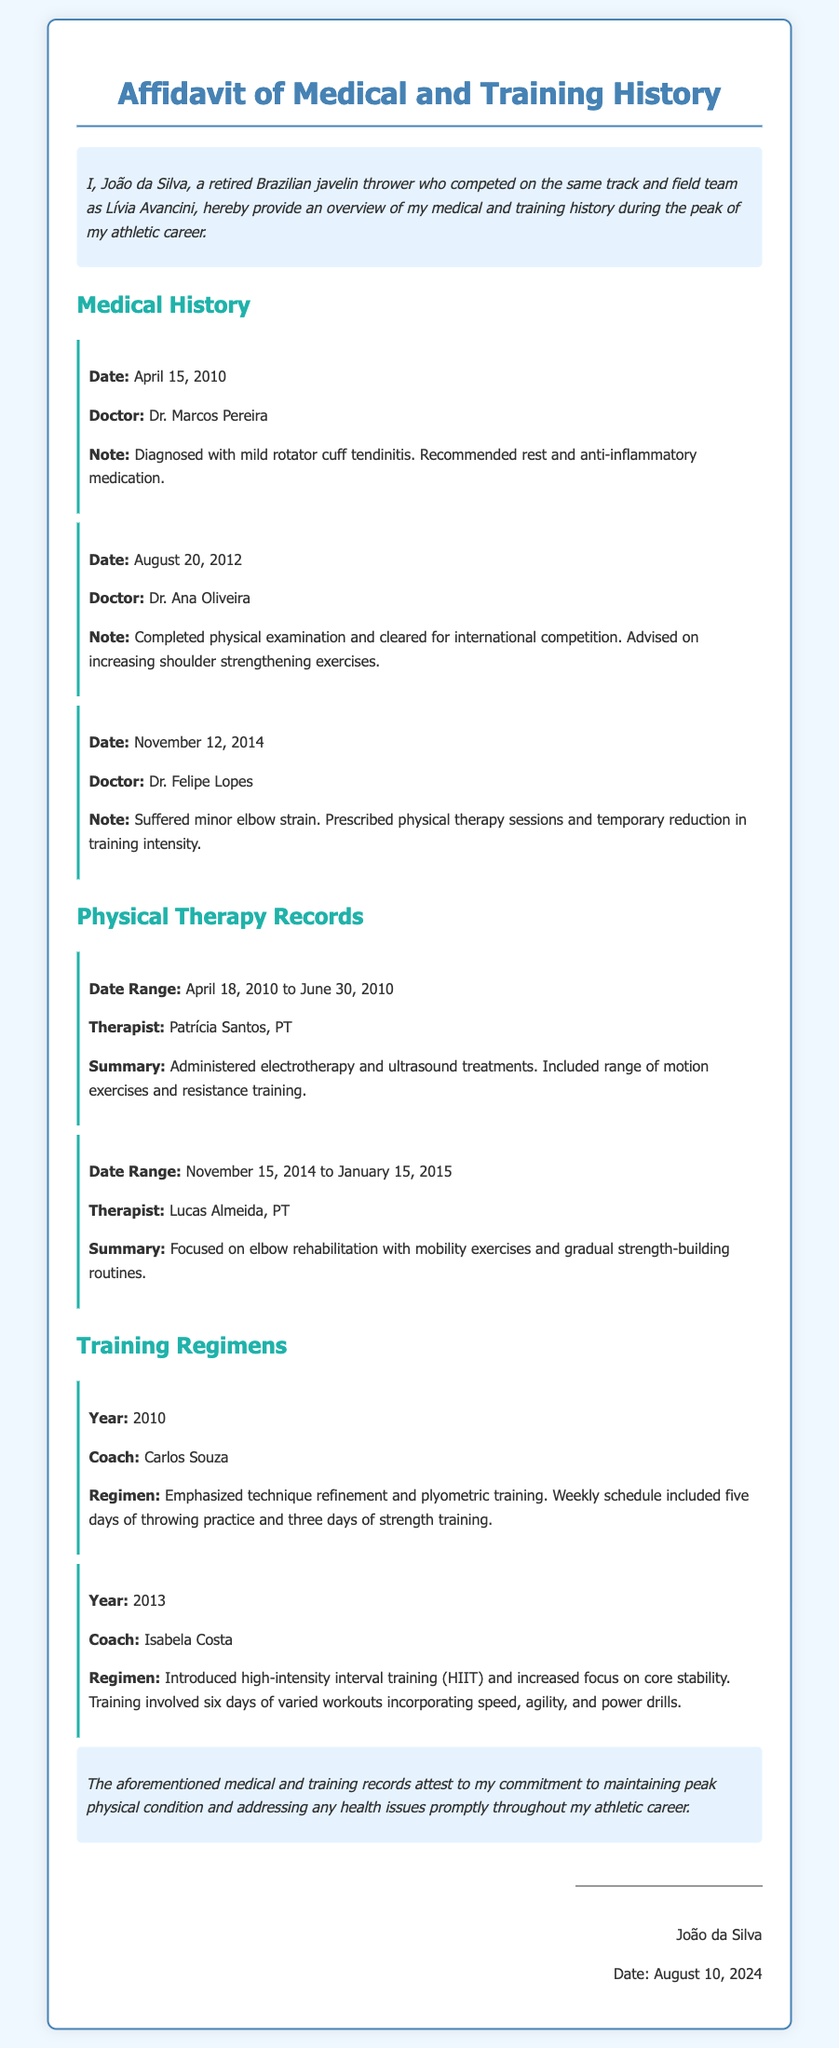what is the name of the affidavit? The title of the affidavit is mentioned at the top of the document.
Answer: Affidavit of Medical and Training History who diagnosed João with tendinitis? The doctor's name is specified in the medical note regarding the diagnosis of tendinitis.
Answer: Dr. Marcos Pereira what was recommended after the elbow strain? The action advised following the elbow strain is detailed in the associated medical note.
Answer: Physical therapy sessions who administered therapy from April to June 2010? The therapist's name is provided in the physical therapy records section for the specified date range.
Answer: Patrícia Santos what type of training was emphasized in 2010? The focus of the training regimen for the specified year is clearly stated.
Answer: Technique refinement what was the date of the last medical note? The date is indicated in one of the medical notes within the document.
Answer: November 12, 2014 how long did the therapy for elbow rehabilitation last? The duration of the therapy is noted in the physical therapy records section.
Answer: Two months how many days a week did the 2010 training regimen include throwing practice? The training schedule details the number of days dedicated to throwing practice that year.
Answer: Five days 